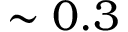Convert formula to latex. <formula><loc_0><loc_0><loc_500><loc_500>\sim 0 . 3</formula> 